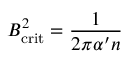Convert formula to latex. <formula><loc_0><loc_0><loc_500><loc_500>B _ { c r i t } ^ { 2 } = \frac { 1 } { 2 \pi \alpha ^ { \prime } n }</formula> 